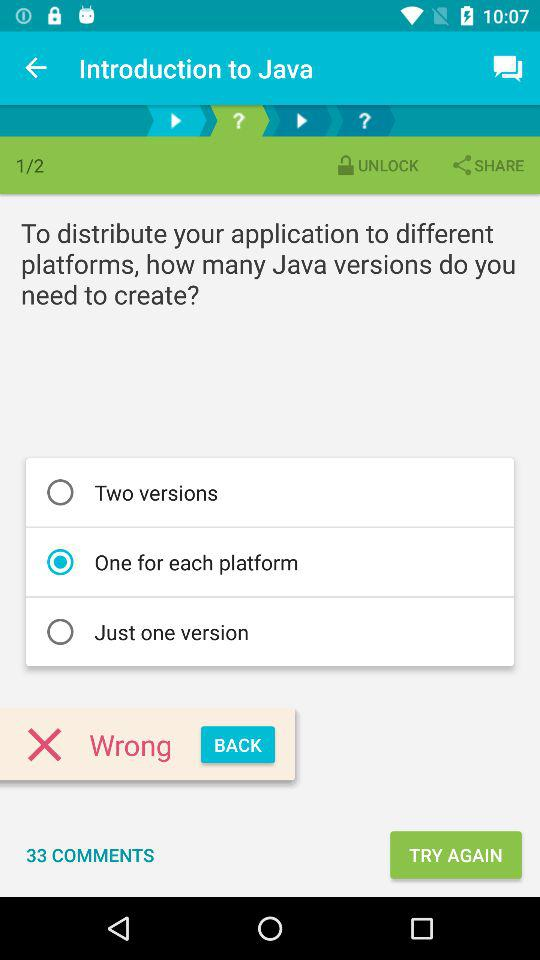How many comments are there? There are 33 comments. 